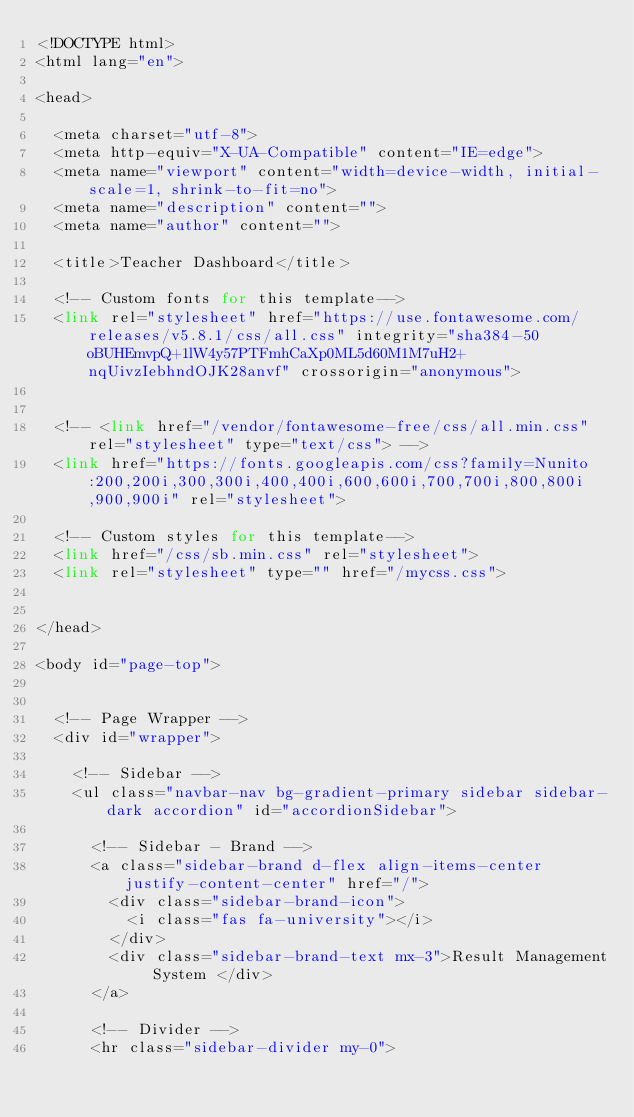<code> <loc_0><loc_0><loc_500><loc_500><_PHP_><!DOCTYPE html>
<html lang="en">

<head>

  <meta charset="utf-8">
  <meta http-equiv="X-UA-Compatible" content="IE=edge">
  <meta name="viewport" content="width=device-width, initial-scale=1, shrink-to-fit=no">
  <meta name="description" content="">
  <meta name="author" content="">

  <title>Teacher Dashboard</title>

  <!-- Custom fonts for this template-->
  <link rel="stylesheet" href="https://use.fontawesome.com/releases/v5.8.1/css/all.css" integrity="sha384-50oBUHEmvpQ+1lW4y57PTFmhCaXp0ML5d60M1M7uH2+nqUivzIebhndOJK28anvf" crossorigin="anonymous">


  <!-- <link href="/vendor/fontawesome-free/css/all.min.css" rel="stylesheet" type="text/css"> -->
  <link href="https://fonts.googleapis.com/css?family=Nunito:200,200i,300,300i,400,400i,600,600i,700,700i,800,800i,900,900i" rel="stylesheet">

  <!-- Custom styles for this template-->
  <link href="/css/sb.min.css" rel="stylesheet">
  <link rel="stylesheet" type="" href="/mycss.css">
  

</head>

<body id="page-top">
  

  <!-- Page Wrapper -->
  <div id="wrapper">

    <!-- Sidebar -->
    <ul class="navbar-nav bg-gradient-primary sidebar sidebar-dark accordion" id="accordionSidebar">

      <!-- Sidebar - Brand -->
      <a class="sidebar-brand d-flex align-items-center justify-content-center" href="/">
        <div class="sidebar-brand-icon">
          <i class="fas fa-university"></i>
        </div>
        <div class="sidebar-brand-text mx-3">Result Management System </div>
      </a>

      <!-- Divider -->
      <hr class="sidebar-divider my-0"></code> 